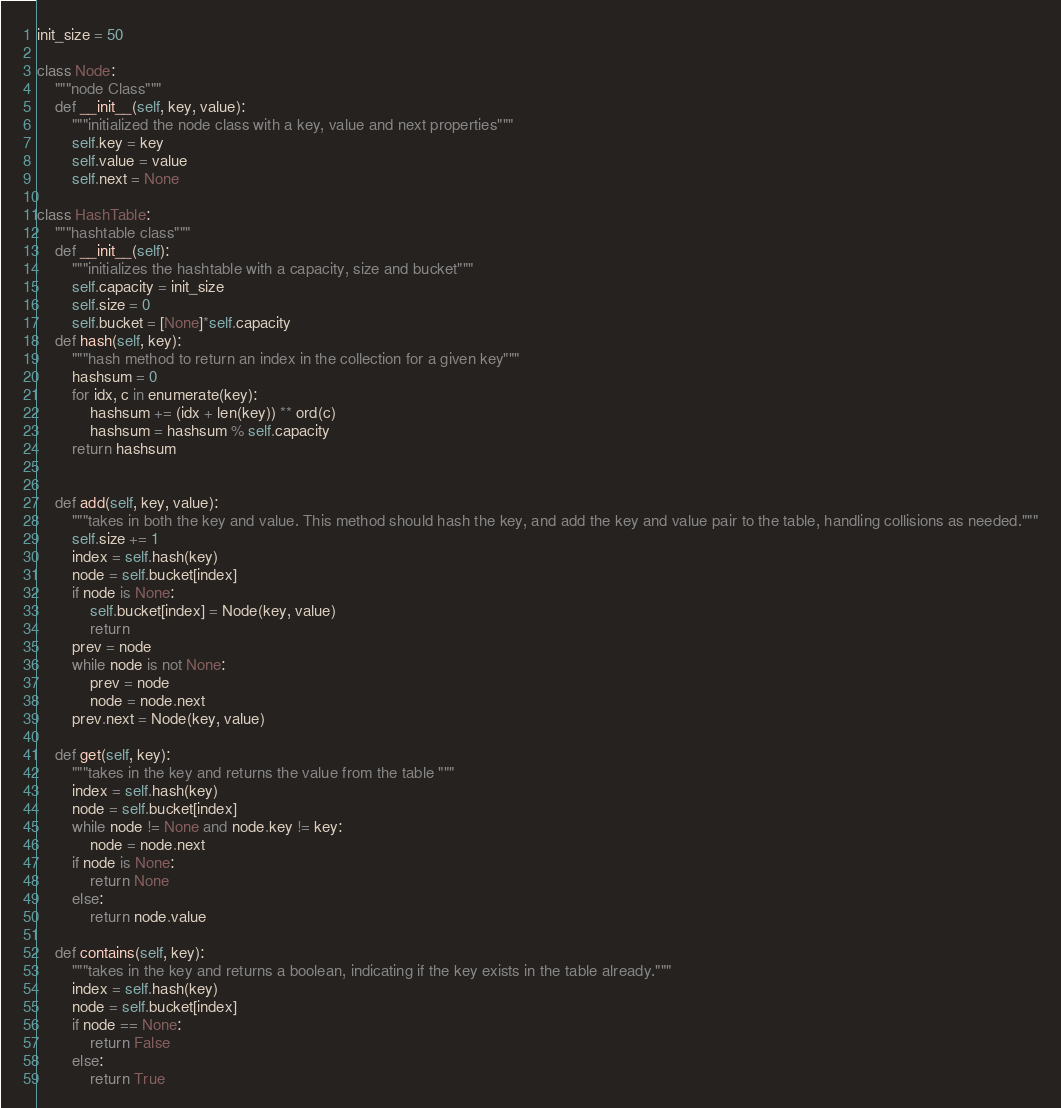<code> <loc_0><loc_0><loc_500><loc_500><_Python_>init_size = 50

class Node:
    """node Class"""
    def __init__(self, key, value):
        """initialized the node class with a key, value and next properties"""
        self.key = key
        self.value = value
        self.next = None

class HashTable:
    """hashtable class"""
    def __init__(self):
        """initializes the hashtable with a capacity, size and bucket"""
        self.capacity = init_size
        self.size = 0
        self.bucket = [None]*self.capacity
    def hash(self, key):
        """hash method to return an index in the collection for a given key"""
        hashsum = 0
        for idx, c in enumerate(key):
            hashsum += (idx + len(key)) ** ord(c)
            hashsum = hashsum % self.capacity
        return hashsum


    def add(self, key, value):
        """takes in both the key and value. This method should hash the key, and add the key and value pair to the table, handling collisions as needed."""
        self.size += 1
        index = self.hash(key)
        node = self.bucket[index]
        if node is None:
            self.bucket[index] = Node(key, value)
            return
        prev = node 
        while node is not None:
            prev = node 
            node = node.next
        prev.next = Node(key, value)

    def get(self, key):
        """takes in the key and returns the value from the table """
        index = self.hash(key)
        node = self.bucket[index]
        while node != None and node.key != key:
            node = node.next
        if node is None:
            return None
        else:
            return node.value

    def contains(self, key):
        """takes in the key and returns a boolean, indicating if the key exists in the table already."""
        index = self.hash(key)
        node = self.bucket[index]
        if node == None:
            return False
        else:
            return True</code> 